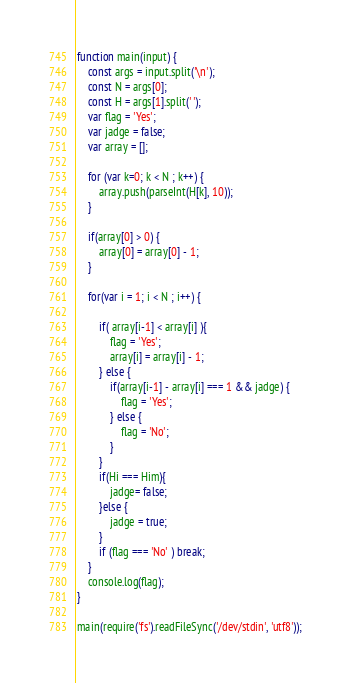Convert code to text. <code><loc_0><loc_0><loc_500><loc_500><_JavaScript_>function main(input) {
    const args = input.split('\n');
    const N = args[0];
    const H = args[1].split(' ');
    var flag = 'Yes';
    var jadge = false;
    var array = [];

    for (var k=0; k < N ; k++) {
        array.push(parseInt(H[k], 10));
    }

    if(array[0] > 0) {
        array[0] = array[0] - 1;
    }

    for(var i = 1; i < N ; i++) {

        if( array[i-1] < array[i] ){
            flag = 'Yes';
            array[i] = array[i] - 1;
        } else {
            if(array[i-1] - array[i] === 1 && jadge) {
                flag = 'Yes';
            } else {
                flag = 'No';
            }
        }
        if(Hi === Him){
            jadge= false;
        }else {
            jadge = true;
        }
        if (flag === 'No' ) break;
    }
    console.log(flag);
}

main(require('fs').readFileSync('/dev/stdin', 'utf8'));
</code> 